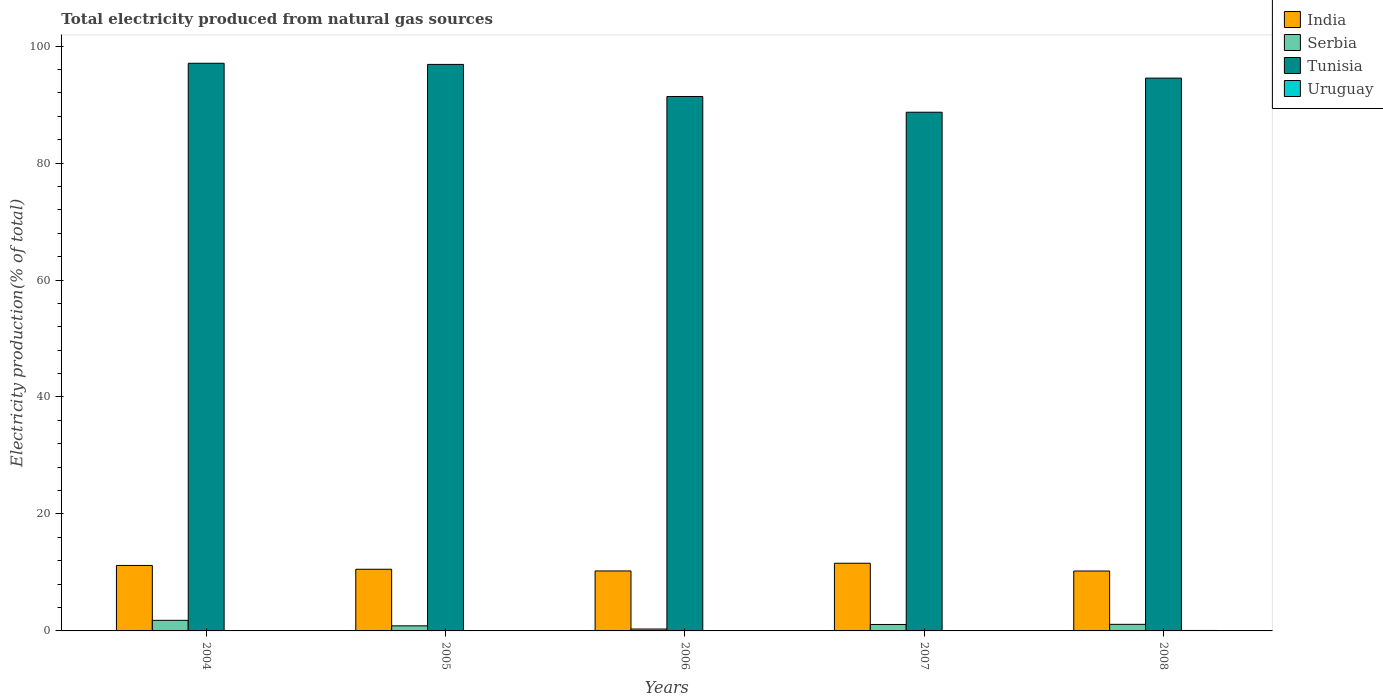How many different coloured bars are there?
Your answer should be very brief. 4. Are the number of bars per tick equal to the number of legend labels?
Provide a short and direct response. Yes. Are the number of bars on each tick of the X-axis equal?
Give a very brief answer. Yes. How many bars are there on the 5th tick from the left?
Your response must be concise. 4. How many bars are there on the 1st tick from the right?
Provide a succinct answer. 4. What is the label of the 3rd group of bars from the left?
Give a very brief answer. 2006. In how many cases, is the number of bars for a given year not equal to the number of legend labels?
Your answer should be compact. 0. What is the total electricity produced in Tunisia in 2006?
Offer a very short reply. 91.39. Across all years, what is the maximum total electricity produced in Tunisia?
Offer a very short reply. 97.07. Across all years, what is the minimum total electricity produced in India?
Ensure brevity in your answer.  10.24. In which year was the total electricity produced in Tunisia maximum?
Give a very brief answer. 2004. In which year was the total electricity produced in Uruguay minimum?
Offer a terse response. 2007. What is the total total electricity produced in Serbia in the graph?
Keep it short and to the point. 5.23. What is the difference between the total electricity produced in India in 2005 and that in 2007?
Your answer should be very brief. -1.03. What is the difference between the total electricity produced in Tunisia in 2006 and the total electricity produced in India in 2004?
Give a very brief answer. 80.19. What is the average total electricity produced in Uruguay per year?
Give a very brief answer. 0.05. In the year 2006, what is the difference between the total electricity produced in Serbia and total electricity produced in Tunisia?
Offer a terse response. -91.06. In how many years, is the total electricity produced in Tunisia greater than 12 %?
Your response must be concise. 5. What is the ratio of the total electricity produced in India in 2004 to that in 2006?
Make the answer very short. 1.09. Is the total electricity produced in India in 2004 less than that in 2006?
Your answer should be very brief. No. What is the difference between the highest and the second highest total electricity produced in India?
Keep it short and to the point. 0.38. What is the difference between the highest and the lowest total electricity produced in Uruguay?
Give a very brief answer. 0.06. In how many years, is the total electricity produced in Tunisia greater than the average total electricity produced in Tunisia taken over all years?
Provide a short and direct response. 3. Is the sum of the total electricity produced in Serbia in 2005 and 2006 greater than the maximum total electricity produced in Tunisia across all years?
Provide a succinct answer. No. Is it the case that in every year, the sum of the total electricity produced in India and total electricity produced in Serbia is greater than the sum of total electricity produced in Uruguay and total electricity produced in Tunisia?
Offer a very short reply. No. What does the 2nd bar from the left in 2006 represents?
Keep it short and to the point. Serbia. What does the 3rd bar from the right in 2005 represents?
Keep it short and to the point. Serbia. Are all the bars in the graph horizontal?
Ensure brevity in your answer.  No. Are the values on the major ticks of Y-axis written in scientific E-notation?
Offer a very short reply. No. Does the graph contain any zero values?
Provide a succinct answer. No. Does the graph contain grids?
Make the answer very short. No. Where does the legend appear in the graph?
Give a very brief answer. Top right. What is the title of the graph?
Give a very brief answer. Total electricity produced from natural gas sources. What is the Electricity production(% of total) in India in 2004?
Your answer should be very brief. 11.2. What is the Electricity production(% of total) in Serbia in 2004?
Provide a succinct answer. 1.81. What is the Electricity production(% of total) in Tunisia in 2004?
Ensure brevity in your answer.  97.07. What is the Electricity production(% of total) in Uruguay in 2004?
Ensure brevity in your answer.  0.03. What is the Electricity production(% of total) of India in 2005?
Provide a succinct answer. 10.55. What is the Electricity production(% of total) in Serbia in 2005?
Ensure brevity in your answer.  0.87. What is the Electricity production(% of total) of Tunisia in 2005?
Offer a terse response. 96.87. What is the Electricity production(% of total) in Uruguay in 2005?
Ensure brevity in your answer.  0.04. What is the Electricity production(% of total) in India in 2006?
Offer a terse response. 10.26. What is the Electricity production(% of total) in Serbia in 2006?
Offer a very short reply. 0.32. What is the Electricity production(% of total) of Tunisia in 2006?
Your answer should be compact. 91.39. What is the Electricity production(% of total) in Uruguay in 2006?
Your answer should be compact. 0.05. What is the Electricity production(% of total) in India in 2007?
Offer a very short reply. 11.57. What is the Electricity production(% of total) in Serbia in 2007?
Your response must be concise. 1.1. What is the Electricity production(% of total) of Tunisia in 2007?
Make the answer very short. 88.7. What is the Electricity production(% of total) of Uruguay in 2007?
Your response must be concise. 0.02. What is the Electricity production(% of total) in India in 2008?
Offer a terse response. 10.24. What is the Electricity production(% of total) in Serbia in 2008?
Ensure brevity in your answer.  1.13. What is the Electricity production(% of total) of Tunisia in 2008?
Provide a short and direct response. 94.53. What is the Electricity production(% of total) in Uruguay in 2008?
Provide a short and direct response. 0.08. Across all years, what is the maximum Electricity production(% of total) in India?
Your answer should be very brief. 11.57. Across all years, what is the maximum Electricity production(% of total) of Serbia?
Your answer should be very brief. 1.81. Across all years, what is the maximum Electricity production(% of total) of Tunisia?
Provide a short and direct response. 97.07. Across all years, what is the maximum Electricity production(% of total) of Uruguay?
Ensure brevity in your answer.  0.08. Across all years, what is the minimum Electricity production(% of total) of India?
Provide a succinct answer. 10.24. Across all years, what is the minimum Electricity production(% of total) of Serbia?
Provide a short and direct response. 0.32. Across all years, what is the minimum Electricity production(% of total) in Tunisia?
Offer a terse response. 88.7. Across all years, what is the minimum Electricity production(% of total) in Uruguay?
Your response must be concise. 0.02. What is the total Electricity production(% of total) in India in the graph?
Offer a terse response. 53.81. What is the total Electricity production(% of total) in Serbia in the graph?
Your answer should be compact. 5.23. What is the total Electricity production(% of total) of Tunisia in the graph?
Keep it short and to the point. 468.55. What is the total Electricity production(% of total) in Uruguay in the graph?
Provide a succinct answer. 0.23. What is the difference between the Electricity production(% of total) of India in 2004 and that in 2005?
Give a very brief answer. 0.65. What is the difference between the Electricity production(% of total) of Serbia in 2004 and that in 2005?
Provide a short and direct response. 0.94. What is the difference between the Electricity production(% of total) of Tunisia in 2004 and that in 2005?
Ensure brevity in your answer.  0.2. What is the difference between the Electricity production(% of total) in Uruguay in 2004 and that in 2005?
Provide a succinct answer. -0.01. What is the difference between the Electricity production(% of total) in India in 2004 and that in 2006?
Provide a succinct answer. 0.94. What is the difference between the Electricity production(% of total) of Serbia in 2004 and that in 2006?
Offer a terse response. 1.49. What is the difference between the Electricity production(% of total) in Tunisia in 2004 and that in 2006?
Provide a succinct answer. 5.68. What is the difference between the Electricity production(% of total) in Uruguay in 2004 and that in 2006?
Make the answer very short. -0.02. What is the difference between the Electricity production(% of total) in India in 2004 and that in 2007?
Give a very brief answer. -0.38. What is the difference between the Electricity production(% of total) of Serbia in 2004 and that in 2007?
Ensure brevity in your answer.  0.71. What is the difference between the Electricity production(% of total) of Tunisia in 2004 and that in 2007?
Give a very brief answer. 8.37. What is the difference between the Electricity production(% of total) in Uruguay in 2004 and that in 2007?
Offer a very short reply. 0.01. What is the difference between the Electricity production(% of total) in India in 2004 and that in 2008?
Provide a succinct answer. 0.95. What is the difference between the Electricity production(% of total) in Serbia in 2004 and that in 2008?
Make the answer very short. 0.68. What is the difference between the Electricity production(% of total) in Tunisia in 2004 and that in 2008?
Provide a short and direct response. 2.54. What is the difference between the Electricity production(% of total) in Uruguay in 2004 and that in 2008?
Your answer should be compact. -0.05. What is the difference between the Electricity production(% of total) of India in 2005 and that in 2006?
Give a very brief answer. 0.29. What is the difference between the Electricity production(% of total) of Serbia in 2005 and that in 2006?
Offer a terse response. 0.55. What is the difference between the Electricity production(% of total) in Tunisia in 2005 and that in 2006?
Give a very brief answer. 5.49. What is the difference between the Electricity production(% of total) of Uruguay in 2005 and that in 2006?
Give a very brief answer. -0.01. What is the difference between the Electricity production(% of total) in India in 2005 and that in 2007?
Give a very brief answer. -1.03. What is the difference between the Electricity production(% of total) of Serbia in 2005 and that in 2007?
Give a very brief answer. -0.23. What is the difference between the Electricity production(% of total) of Tunisia in 2005 and that in 2007?
Your answer should be compact. 8.18. What is the difference between the Electricity production(% of total) of Uruguay in 2005 and that in 2007?
Offer a terse response. 0.02. What is the difference between the Electricity production(% of total) of India in 2005 and that in 2008?
Your answer should be very brief. 0.3. What is the difference between the Electricity production(% of total) of Serbia in 2005 and that in 2008?
Your answer should be compact. -0.26. What is the difference between the Electricity production(% of total) of Tunisia in 2005 and that in 2008?
Make the answer very short. 2.34. What is the difference between the Electricity production(% of total) of Uruguay in 2005 and that in 2008?
Give a very brief answer. -0.04. What is the difference between the Electricity production(% of total) in India in 2006 and that in 2007?
Offer a terse response. -1.32. What is the difference between the Electricity production(% of total) of Serbia in 2006 and that in 2007?
Your answer should be very brief. -0.78. What is the difference between the Electricity production(% of total) in Tunisia in 2006 and that in 2007?
Offer a very short reply. 2.69. What is the difference between the Electricity production(% of total) of Uruguay in 2006 and that in 2007?
Provide a succinct answer. 0.03. What is the difference between the Electricity production(% of total) of India in 2006 and that in 2008?
Keep it short and to the point. 0.01. What is the difference between the Electricity production(% of total) in Serbia in 2006 and that in 2008?
Give a very brief answer. -0.8. What is the difference between the Electricity production(% of total) in Tunisia in 2006 and that in 2008?
Offer a terse response. -3.14. What is the difference between the Electricity production(% of total) in Uruguay in 2006 and that in 2008?
Offer a terse response. -0.03. What is the difference between the Electricity production(% of total) of India in 2007 and that in 2008?
Give a very brief answer. 1.33. What is the difference between the Electricity production(% of total) of Serbia in 2007 and that in 2008?
Your answer should be very brief. -0.02. What is the difference between the Electricity production(% of total) in Tunisia in 2007 and that in 2008?
Provide a short and direct response. -5.83. What is the difference between the Electricity production(% of total) of Uruguay in 2007 and that in 2008?
Provide a short and direct response. -0.06. What is the difference between the Electricity production(% of total) in India in 2004 and the Electricity production(% of total) in Serbia in 2005?
Provide a succinct answer. 10.33. What is the difference between the Electricity production(% of total) of India in 2004 and the Electricity production(% of total) of Tunisia in 2005?
Offer a very short reply. -85.68. What is the difference between the Electricity production(% of total) of India in 2004 and the Electricity production(% of total) of Uruguay in 2005?
Ensure brevity in your answer.  11.16. What is the difference between the Electricity production(% of total) of Serbia in 2004 and the Electricity production(% of total) of Tunisia in 2005?
Provide a succinct answer. -95.06. What is the difference between the Electricity production(% of total) in Serbia in 2004 and the Electricity production(% of total) in Uruguay in 2005?
Offer a terse response. 1.77. What is the difference between the Electricity production(% of total) in Tunisia in 2004 and the Electricity production(% of total) in Uruguay in 2005?
Offer a very short reply. 97.03. What is the difference between the Electricity production(% of total) of India in 2004 and the Electricity production(% of total) of Serbia in 2006?
Provide a short and direct response. 10.87. What is the difference between the Electricity production(% of total) in India in 2004 and the Electricity production(% of total) in Tunisia in 2006?
Your answer should be compact. -80.19. What is the difference between the Electricity production(% of total) of India in 2004 and the Electricity production(% of total) of Uruguay in 2006?
Provide a short and direct response. 11.14. What is the difference between the Electricity production(% of total) of Serbia in 2004 and the Electricity production(% of total) of Tunisia in 2006?
Give a very brief answer. -89.58. What is the difference between the Electricity production(% of total) of Serbia in 2004 and the Electricity production(% of total) of Uruguay in 2006?
Your answer should be compact. 1.76. What is the difference between the Electricity production(% of total) in Tunisia in 2004 and the Electricity production(% of total) in Uruguay in 2006?
Your response must be concise. 97.02. What is the difference between the Electricity production(% of total) in India in 2004 and the Electricity production(% of total) in Serbia in 2007?
Your answer should be compact. 10.09. What is the difference between the Electricity production(% of total) of India in 2004 and the Electricity production(% of total) of Tunisia in 2007?
Keep it short and to the point. -77.5. What is the difference between the Electricity production(% of total) of India in 2004 and the Electricity production(% of total) of Uruguay in 2007?
Make the answer very short. 11.17. What is the difference between the Electricity production(% of total) of Serbia in 2004 and the Electricity production(% of total) of Tunisia in 2007?
Keep it short and to the point. -86.89. What is the difference between the Electricity production(% of total) in Serbia in 2004 and the Electricity production(% of total) in Uruguay in 2007?
Offer a very short reply. 1.79. What is the difference between the Electricity production(% of total) in Tunisia in 2004 and the Electricity production(% of total) in Uruguay in 2007?
Give a very brief answer. 97.05. What is the difference between the Electricity production(% of total) in India in 2004 and the Electricity production(% of total) in Serbia in 2008?
Offer a very short reply. 10.07. What is the difference between the Electricity production(% of total) of India in 2004 and the Electricity production(% of total) of Tunisia in 2008?
Ensure brevity in your answer.  -83.33. What is the difference between the Electricity production(% of total) in India in 2004 and the Electricity production(% of total) in Uruguay in 2008?
Provide a short and direct response. 11.12. What is the difference between the Electricity production(% of total) of Serbia in 2004 and the Electricity production(% of total) of Tunisia in 2008?
Your answer should be compact. -92.72. What is the difference between the Electricity production(% of total) of Serbia in 2004 and the Electricity production(% of total) of Uruguay in 2008?
Give a very brief answer. 1.73. What is the difference between the Electricity production(% of total) of Tunisia in 2004 and the Electricity production(% of total) of Uruguay in 2008?
Your answer should be very brief. 96.99. What is the difference between the Electricity production(% of total) of India in 2005 and the Electricity production(% of total) of Serbia in 2006?
Offer a terse response. 10.22. What is the difference between the Electricity production(% of total) in India in 2005 and the Electricity production(% of total) in Tunisia in 2006?
Your answer should be very brief. -80.84. What is the difference between the Electricity production(% of total) of India in 2005 and the Electricity production(% of total) of Uruguay in 2006?
Your answer should be compact. 10.49. What is the difference between the Electricity production(% of total) in Serbia in 2005 and the Electricity production(% of total) in Tunisia in 2006?
Ensure brevity in your answer.  -90.52. What is the difference between the Electricity production(% of total) of Serbia in 2005 and the Electricity production(% of total) of Uruguay in 2006?
Provide a succinct answer. 0.82. What is the difference between the Electricity production(% of total) of Tunisia in 2005 and the Electricity production(% of total) of Uruguay in 2006?
Give a very brief answer. 96.82. What is the difference between the Electricity production(% of total) of India in 2005 and the Electricity production(% of total) of Serbia in 2007?
Give a very brief answer. 9.44. What is the difference between the Electricity production(% of total) of India in 2005 and the Electricity production(% of total) of Tunisia in 2007?
Your answer should be very brief. -78.15. What is the difference between the Electricity production(% of total) of India in 2005 and the Electricity production(% of total) of Uruguay in 2007?
Make the answer very short. 10.52. What is the difference between the Electricity production(% of total) in Serbia in 2005 and the Electricity production(% of total) in Tunisia in 2007?
Give a very brief answer. -87.83. What is the difference between the Electricity production(% of total) in Serbia in 2005 and the Electricity production(% of total) in Uruguay in 2007?
Your response must be concise. 0.85. What is the difference between the Electricity production(% of total) of Tunisia in 2005 and the Electricity production(% of total) of Uruguay in 2007?
Your answer should be very brief. 96.85. What is the difference between the Electricity production(% of total) in India in 2005 and the Electricity production(% of total) in Serbia in 2008?
Your answer should be compact. 9.42. What is the difference between the Electricity production(% of total) in India in 2005 and the Electricity production(% of total) in Tunisia in 2008?
Your answer should be very brief. -83.98. What is the difference between the Electricity production(% of total) in India in 2005 and the Electricity production(% of total) in Uruguay in 2008?
Ensure brevity in your answer.  10.47. What is the difference between the Electricity production(% of total) in Serbia in 2005 and the Electricity production(% of total) in Tunisia in 2008?
Your answer should be compact. -93.66. What is the difference between the Electricity production(% of total) in Serbia in 2005 and the Electricity production(% of total) in Uruguay in 2008?
Ensure brevity in your answer.  0.79. What is the difference between the Electricity production(% of total) of Tunisia in 2005 and the Electricity production(% of total) of Uruguay in 2008?
Ensure brevity in your answer.  96.79. What is the difference between the Electricity production(% of total) in India in 2006 and the Electricity production(% of total) in Serbia in 2007?
Offer a terse response. 9.15. What is the difference between the Electricity production(% of total) of India in 2006 and the Electricity production(% of total) of Tunisia in 2007?
Make the answer very short. -78.44. What is the difference between the Electricity production(% of total) of India in 2006 and the Electricity production(% of total) of Uruguay in 2007?
Your response must be concise. 10.24. What is the difference between the Electricity production(% of total) of Serbia in 2006 and the Electricity production(% of total) of Tunisia in 2007?
Your answer should be compact. -88.37. What is the difference between the Electricity production(% of total) of Serbia in 2006 and the Electricity production(% of total) of Uruguay in 2007?
Offer a terse response. 0.3. What is the difference between the Electricity production(% of total) in Tunisia in 2006 and the Electricity production(% of total) in Uruguay in 2007?
Keep it short and to the point. 91.37. What is the difference between the Electricity production(% of total) in India in 2006 and the Electricity production(% of total) in Serbia in 2008?
Offer a very short reply. 9.13. What is the difference between the Electricity production(% of total) of India in 2006 and the Electricity production(% of total) of Tunisia in 2008?
Your answer should be very brief. -84.27. What is the difference between the Electricity production(% of total) in India in 2006 and the Electricity production(% of total) in Uruguay in 2008?
Give a very brief answer. 10.18. What is the difference between the Electricity production(% of total) in Serbia in 2006 and the Electricity production(% of total) in Tunisia in 2008?
Provide a succinct answer. -94.2. What is the difference between the Electricity production(% of total) in Serbia in 2006 and the Electricity production(% of total) in Uruguay in 2008?
Your answer should be compact. 0.24. What is the difference between the Electricity production(% of total) in Tunisia in 2006 and the Electricity production(% of total) in Uruguay in 2008?
Ensure brevity in your answer.  91.31. What is the difference between the Electricity production(% of total) of India in 2007 and the Electricity production(% of total) of Serbia in 2008?
Make the answer very short. 10.45. What is the difference between the Electricity production(% of total) in India in 2007 and the Electricity production(% of total) in Tunisia in 2008?
Ensure brevity in your answer.  -82.96. What is the difference between the Electricity production(% of total) of India in 2007 and the Electricity production(% of total) of Uruguay in 2008?
Provide a succinct answer. 11.49. What is the difference between the Electricity production(% of total) in Serbia in 2007 and the Electricity production(% of total) in Tunisia in 2008?
Keep it short and to the point. -93.42. What is the difference between the Electricity production(% of total) in Serbia in 2007 and the Electricity production(% of total) in Uruguay in 2008?
Your answer should be compact. 1.02. What is the difference between the Electricity production(% of total) in Tunisia in 2007 and the Electricity production(% of total) in Uruguay in 2008?
Ensure brevity in your answer.  88.62. What is the average Electricity production(% of total) in India per year?
Your answer should be compact. 10.76. What is the average Electricity production(% of total) of Serbia per year?
Provide a short and direct response. 1.05. What is the average Electricity production(% of total) of Tunisia per year?
Your response must be concise. 93.71. What is the average Electricity production(% of total) of Uruguay per year?
Keep it short and to the point. 0.05. In the year 2004, what is the difference between the Electricity production(% of total) in India and Electricity production(% of total) in Serbia?
Your answer should be compact. 9.39. In the year 2004, what is the difference between the Electricity production(% of total) in India and Electricity production(% of total) in Tunisia?
Ensure brevity in your answer.  -85.87. In the year 2004, what is the difference between the Electricity production(% of total) in India and Electricity production(% of total) in Uruguay?
Your answer should be very brief. 11.16. In the year 2004, what is the difference between the Electricity production(% of total) of Serbia and Electricity production(% of total) of Tunisia?
Your response must be concise. -95.26. In the year 2004, what is the difference between the Electricity production(% of total) of Serbia and Electricity production(% of total) of Uruguay?
Provide a succinct answer. 1.78. In the year 2004, what is the difference between the Electricity production(% of total) of Tunisia and Electricity production(% of total) of Uruguay?
Offer a terse response. 97.03. In the year 2005, what is the difference between the Electricity production(% of total) in India and Electricity production(% of total) in Serbia?
Provide a succinct answer. 9.68. In the year 2005, what is the difference between the Electricity production(% of total) of India and Electricity production(% of total) of Tunisia?
Ensure brevity in your answer.  -86.33. In the year 2005, what is the difference between the Electricity production(% of total) in India and Electricity production(% of total) in Uruguay?
Your answer should be compact. 10.51. In the year 2005, what is the difference between the Electricity production(% of total) of Serbia and Electricity production(% of total) of Tunisia?
Offer a terse response. -96. In the year 2005, what is the difference between the Electricity production(% of total) in Serbia and Electricity production(% of total) in Uruguay?
Your response must be concise. 0.83. In the year 2005, what is the difference between the Electricity production(% of total) of Tunisia and Electricity production(% of total) of Uruguay?
Your answer should be compact. 96.83. In the year 2006, what is the difference between the Electricity production(% of total) of India and Electricity production(% of total) of Serbia?
Offer a very short reply. 9.93. In the year 2006, what is the difference between the Electricity production(% of total) of India and Electricity production(% of total) of Tunisia?
Give a very brief answer. -81.13. In the year 2006, what is the difference between the Electricity production(% of total) in India and Electricity production(% of total) in Uruguay?
Make the answer very short. 10.2. In the year 2006, what is the difference between the Electricity production(% of total) of Serbia and Electricity production(% of total) of Tunisia?
Offer a terse response. -91.06. In the year 2006, what is the difference between the Electricity production(% of total) in Serbia and Electricity production(% of total) in Uruguay?
Make the answer very short. 0.27. In the year 2006, what is the difference between the Electricity production(% of total) in Tunisia and Electricity production(% of total) in Uruguay?
Your answer should be compact. 91.33. In the year 2007, what is the difference between the Electricity production(% of total) of India and Electricity production(% of total) of Serbia?
Your answer should be compact. 10.47. In the year 2007, what is the difference between the Electricity production(% of total) of India and Electricity production(% of total) of Tunisia?
Provide a succinct answer. -77.12. In the year 2007, what is the difference between the Electricity production(% of total) in India and Electricity production(% of total) in Uruguay?
Offer a terse response. 11.55. In the year 2007, what is the difference between the Electricity production(% of total) in Serbia and Electricity production(% of total) in Tunisia?
Keep it short and to the point. -87.59. In the year 2007, what is the difference between the Electricity production(% of total) in Serbia and Electricity production(% of total) in Uruguay?
Give a very brief answer. 1.08. In the year 2007, what is the difference between the Electricity production(% of total) in Tunisia and Electricity production(% of total) in Uruguay?
Your answer should be very brief. 88.68. In the year 2008, what is the difference between the Electricity production(% of total) in India and Electricity production(% of total) in Serbia?
Your answer should be very brief. 9.12. In the year 2008, what is the difference between the Electricity production(% of total) in India and Electricity production(% of total) in Tunisia?
Provide a succinct answer. -84.28. In the year 2008, what is the difference between the Electricity production(% of total) in India and Electricity production(% of total) in Uruguay?
Provide a succinct answer. 10.16. In the year 2008, what is the difference between the Electricity production(% of total) in Serbia and Electricity production(% of total) in Tunisia?
Your answer should be compact. -93.4. In the year 2008, what is the difference between the Electricity production(% of total) in Serbia and Electricity production(% of total) in Uruguay?
Offer a very short reply. 1.05. In the year 2008, what is the difference between the Electricity production(% of total) of Tunisia and Electricity production(% of total) of Uruguay?
Your response must be concise. 94.45. What is the ratio of the Electricity production(% of total) in India in 2004 to that in 2005?
Make the answer very short. 1.06. What is the ratio of the Electricity production(% of total) of Serbia in 2004 to that in 2005?
Your response must be concise. 2.08. What is the ratio of the Electricity production(% of total) of Uruguay in 2004 to that in 2005?
Your response must be concise. 0.87. What is the ratio of the Electricity production(% of total) in India in 2004 to that in 2006?
Your response must be concise. 1.09. What is the ratio of the Electricity production(% of total) in Serbia in 2004 to that in 2006?
Give a very brief answer. 5.59. What is the ratio of the Electricity production(% of total) of Tunisia in 2004 to that in 2006?
Keep it short and to the point. 1.06. What is the ratio of the Electricity production(% of total) of Uruguay in 2004 to that in 2006?
Provide a short and direct response. 0.64. What is the ratio of the Electricity production(% of total) in India in 2004 to that in 2007?
Keep it short and to the point. 0.97. What is the ratio of the Electricity production(% of total) in Serbia in 2004 to that in 2007?
Provide a short and direct response. 1.64. What is the ratio of the Electricity production(% of total) in Tunisia in 2004 to that in 2007?
Make the answer very short. 1.09. What is the ratio of the Electricity production(% of total) of Uruguay in 2004 to that in 2007?
Ensure brevity in your answer.  1.6. What is the ratio of the Electricity production(% of total) of India in 2004 to that in 2008?
Keep it short and to the point. 1.09. What is the ratio of the Electricity production(% of total) in Serbia in 2004 to that in 2008?
Ensure brevity in your answer.  1.61. What is the ratio of the Electricity production(% of total) of Tunisia in 2004 to that in 2008?
Offer a very short reply. 1.03. What is the ratio of the Electricity production(% of total) in Uruguay in 2004 to that in 2008?
Ensure brevity in your answer.  0.43. What is the ratio of the Electricity production(% of total) in India in 2005 to that in 2006?
Provide a succinct answer. 1.03. What is the ratio of the Electricity production(% of total) in Serbia in 2005 to that in 2006?
Offer a very short reply. 2.69. What is the ratio of the Electricity production(% of total) of Tunisia in 2005 to that in 2006?
Make the answer very short. 1.06. What is the ratio of the Electricity production(% of total) in Uruguay in 2005 to that in 2006?
Provide a succinct answer. 0.73. What is the ratio of the Electricity production(% of total) of India in 2005 to that in 2007?
Ensure brevity in your answer.  0.91. What is the ratio of the Electricity production(% of total) in Serbia in 2005 to that in 2007?
Provide a short and direct response. 0.79. What is the ratio of the Electricity production(% of total) in Tunisia in 2005 to that in 2007?
Give a very brief answer. 1.09. What is the ratio of the Electricity production(% of total) of Uruguay in 2005 to that in 2007?
Your answer should be compact. 1.84. What is the ratio of the Electricity production(% of total) of India in 2005 to that in 2008?
Provide a succinct answer. 1.03. What is the ratio of the Electricity production(% of total) of Serbia in 2005 to that in 2008?
Your answer should be compact. 0.77. What is the ratio of the Electricity production(% of total) in Tunisia in 2005 to that in 2008?
Offer a terse response. 1.02. What is the ratio of the Electricity production(% of total) in Uruguay in 2005 to that in 2008?
Offer a very short reply. 0.49. What is the ratio of the Electricity production(% of total) of India in 2006 to that in 2007?
Keep it short and to the point. 0.89. What is the ratio of the Electricity production(% of total) in Serbia in 2006 to that in 2007?
Offer a terse response. 0.29. What is the ratio of the Electricity production(% of total) in Tunisia in 2006 to that in 2007?
Provide a short and direct response. 1.03. What is the ratio of the Electricity production(% of total) in Uruguay in 2006 to that in 2007?
Provide a succinct answer. 2.52. What is the ratio of the Electricity production(% of total) in India in 2006 to that in 2008?
Provide a succinct answer. 1. What is the ratio of the Electricity production(% of total) in Serbia in 2006 to that in 2008?
Ensure brevity in your answer.  0.29. What is the ratio of the Electricity production(% of total) of Tunisia in 2006 to that in 2008?
Offer a terse response. 0.97. What is the ratio of the Electricity production(% of total) of Uruguay in 2006 to that in 2008?
Your response must be concise. 0.67. What is the ratio of the Electricity production(% of total) in India in 2007 to that in 2008?
Your answer should be very brief. 1.13. What is the ratio of the Electricity production(% of total) of Serbia in 2007 to that in 2008?
Provide a short and direct response. 0.98. What is the ratio of the Electricity production(% of total) in Tunisia in 2007 to that in 2008?
Your response must be concise. 0.94. What is the ratio of the Electricity production(% of total) in Uruguay in 2007 to that in 2008?
Your response must be concise. 0.27. What is the difference between the highest and the second highest Electricity production(% of total) in India?
Your response must be concise. 0.38. What is the difference between the highest and the second highest Electricity production(% of total) of Serbia?
Make the answer very short. 0.68. What is the difference between the highest and the second highest Electricity production(% of total) of Tunisia?
Your answer should be compact. 0.2. What is the difference between the highest and the second highest Electricity production(% of total) of Uruguay?
Provide a short and direct response. 0.03. What is the difference between the highest and the lowest Electricity production(% of total) of India?
Offer a terse response. 1.33. What is the difference between the highest and the lowest Electricity production(% of total) of Serbia?
Make the answer very short. 1.49. What is the difference between the highest and the lowest Electricity production(% of total) in Tunisia?
Provide a short and direct response. 8.37. What is the difference between the highest and the lowest Electricity production(% of total) in Uruguay?
Your response must be concise. 0.06. 